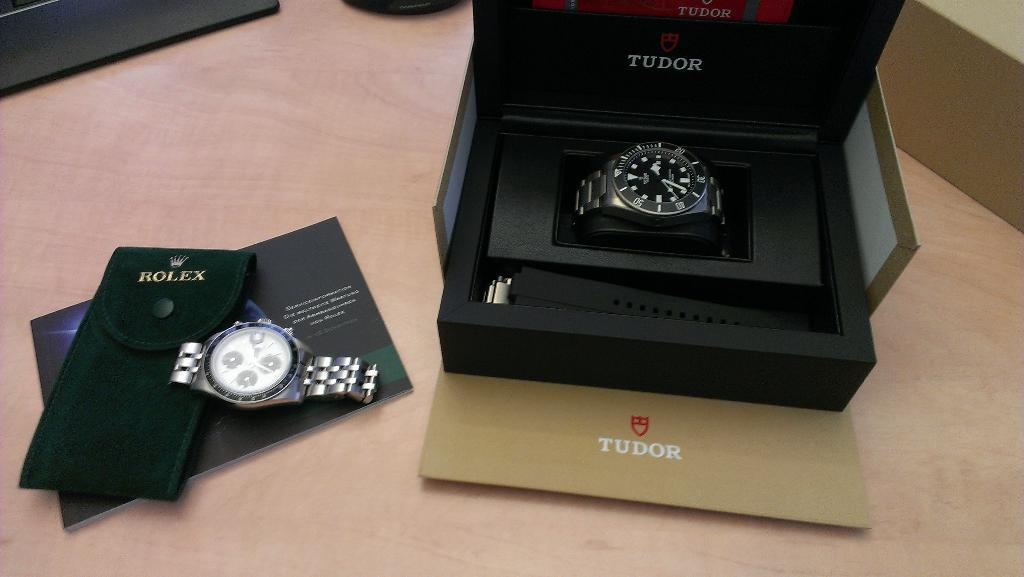<image>
Render a clear and concise summary of the photo. Two expensive watches by Rolex and Tudor being displayed side by side. 